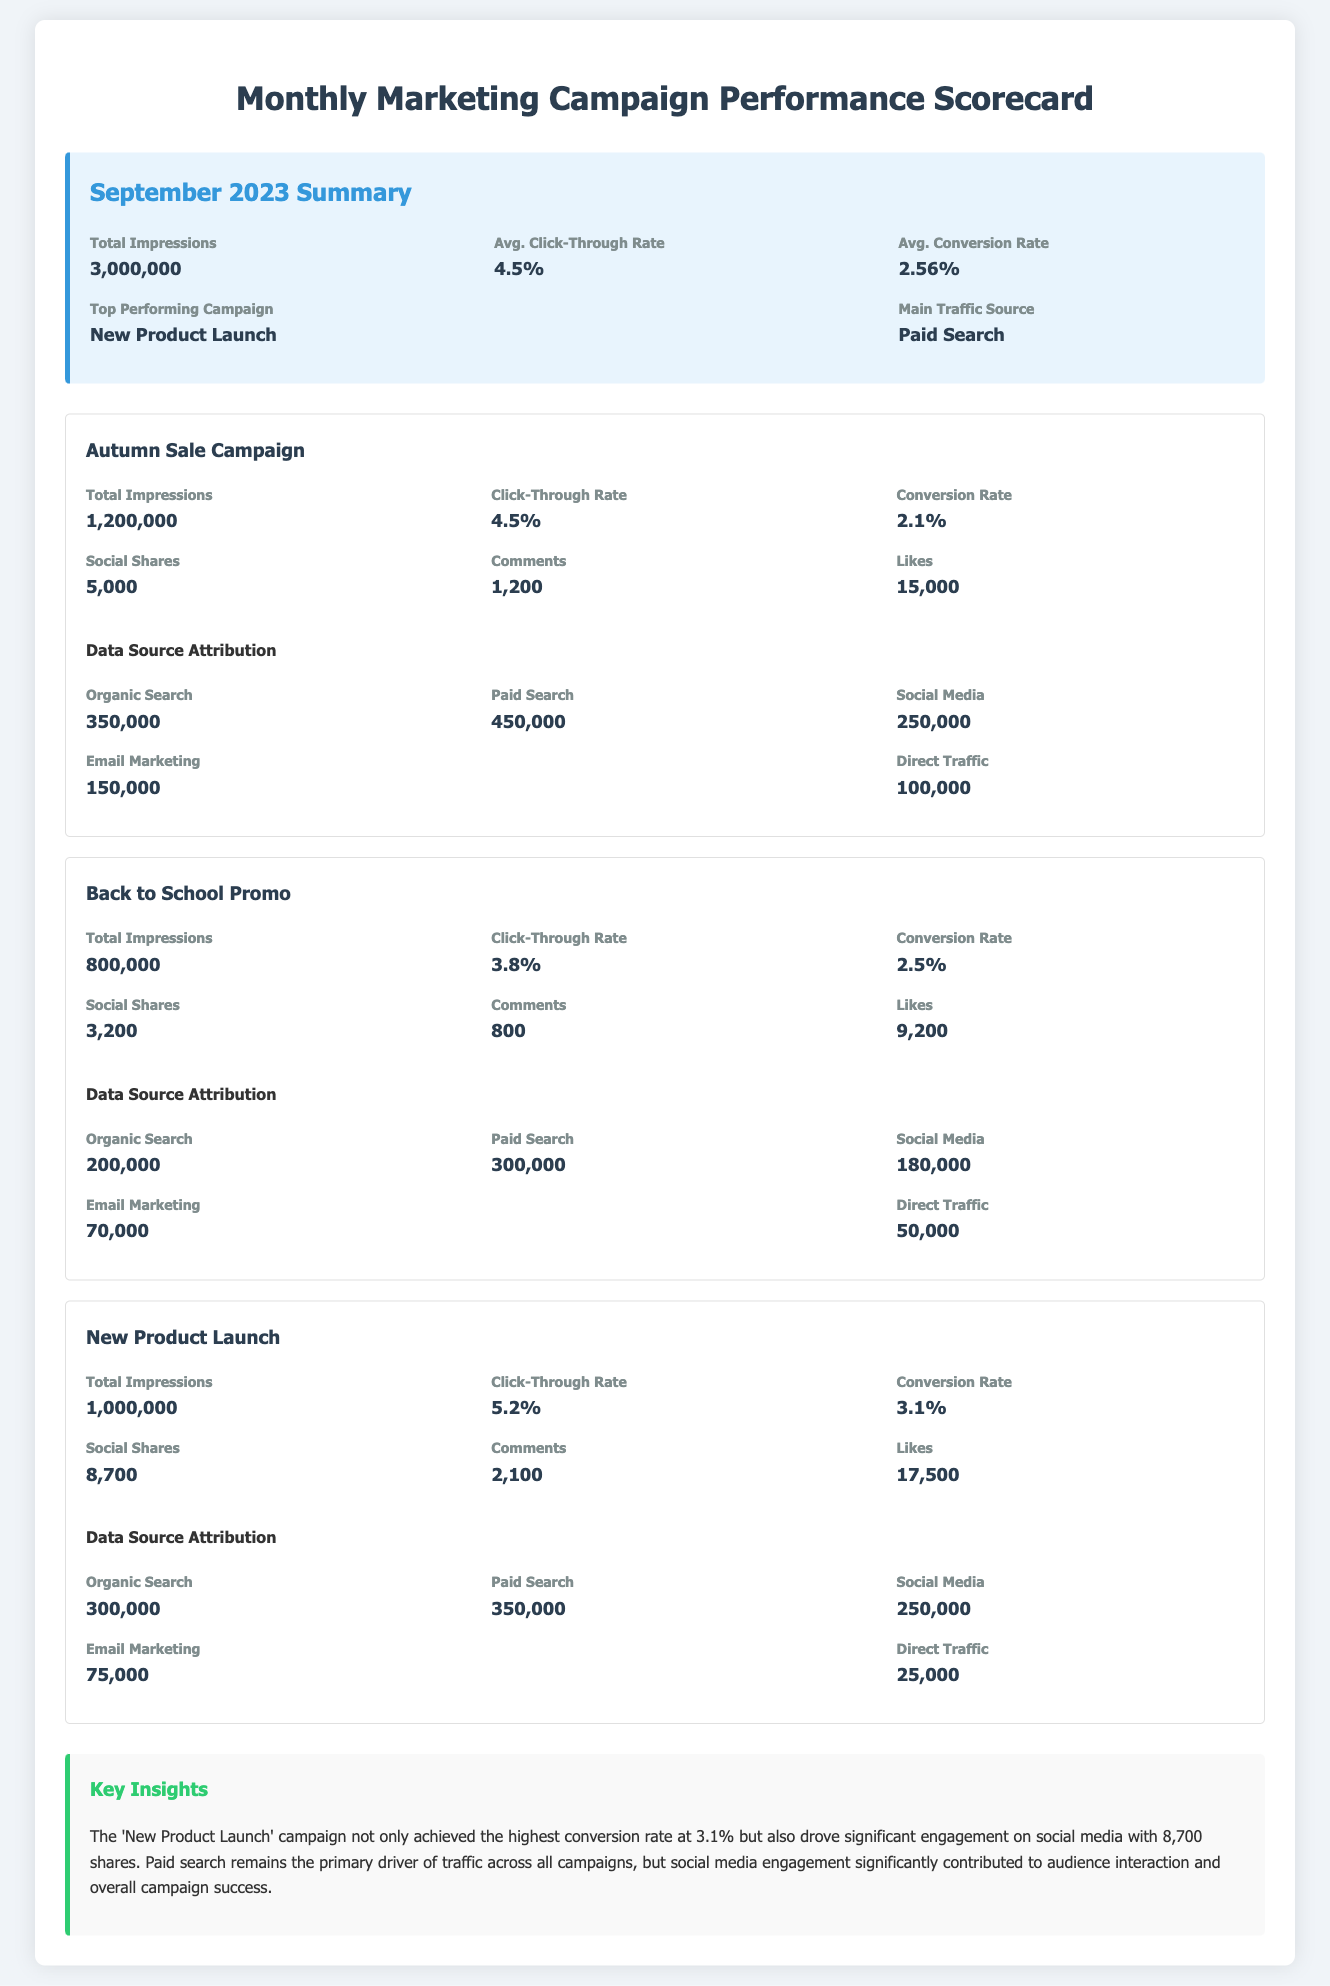What is the total number of impressions for the Autumn Sale Campaign? The total number of impressions is stated directly in the campaign metrics of the document.
Answer: 1,200,000 What is the average conversion rate for the monthly marketing campaigns? The average conversion rate is provided in the summary section of the document.
Answer: 2.56% Which campaign had the highest engagement in terms of social shares? The 'New Product Launch' campaign metrics indicate the highest number of social shares among the listed campaigns.
Answer: 8,700 What is the main traffic source for the September 2023 campaigns? The main traffic source is mentioned in the summary section of the scorecard.
Answer: Paid Search How many comments did the Back to School Promo receive? The number of comments can be found in the metrics of the Back to School Promo campaign.
Answer: 800 Which campaign achieved the highest click-through rate? The click-through rates of each campaign are compared, and 'New Product Launch' has the highest rate.
Answer: 5.2% How many total likes were garnered by the Autumn Sale Campaign? The total likes are recorded in the metrics of the Autumn Sale Campaign.
Answer: 15,000 What is the conversion rate for the New Product Launch? The conversion rate for the New Product Launch campaign is explicitly stated in its metrics.
Answer: 3.1% Which data source contributed the least traffic to the Back to School Promo? The traffic attribution section for the Back to School Promo lists sources, and the one with the least traffic is identified.
Answer: Direct Traffic 